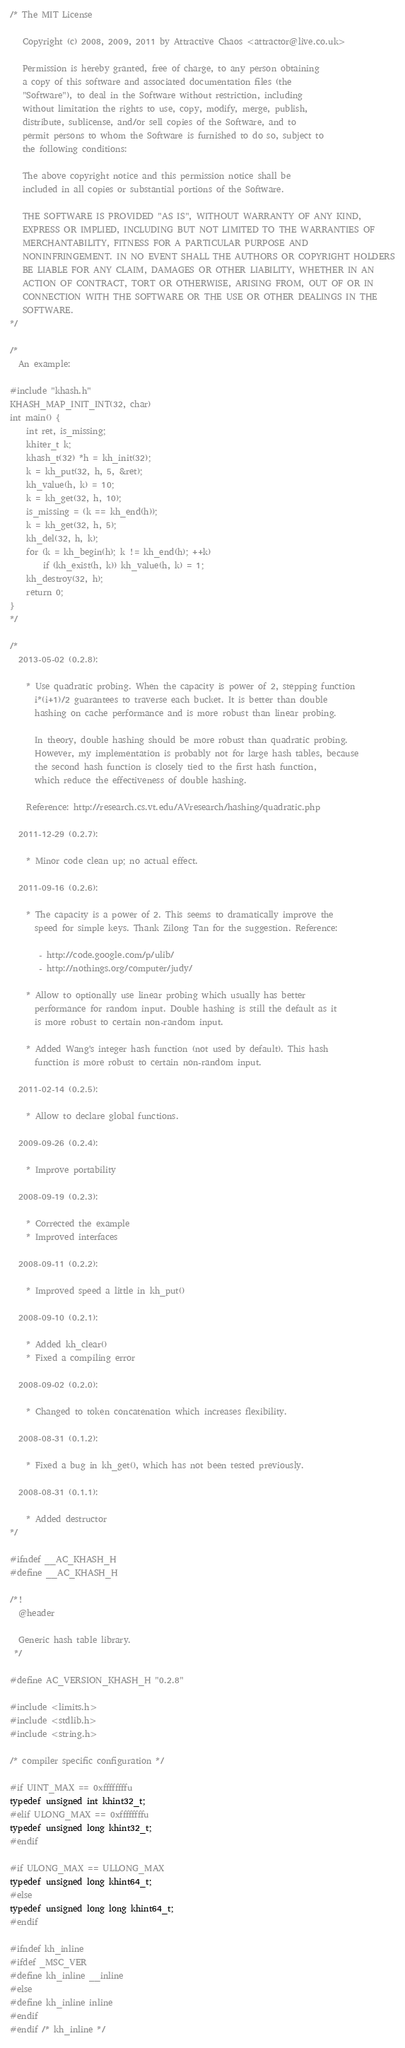Convert code to text. <code><loc_0><loc_0><loc_500><loc_500><_C_>/* The MIT License

   Copyright (c) 2008, 2009, 2011 by Attractive Chaos <attractor@live.co.uk>

   Permission is hereby granted, free of charge, to any person obtaining
   a copy of this software and associated documentation files (the
   "Software"), to deal in the Software without restriction, including
   without limitation the rights to use, copy, modify, merge, publish,
   distribute, sublicense, and/or sell copies of the Software, and to
   permit persons to whom the Software is furnished to do so, subject to
   the following conditions:

   The above copyright notice and this permission notice shall be
   included in all copies or substantial portions of the Software.

   THE SOFTWARE IS PROVIDED "AS IS", WITHOUT WARRANTY OF ANY KIND,
   EXPRESS OR IMPLIED, INCLUDING BUT NOT LIMITED TO THE WARRANTIES OF
   MERCHANTABILITY, FITNESS FOR A PARTICULAR PURPOSE AND
   NONINFRINGEMENT. IN NO EVENT SHALL THE AUTHORS OR COPYRIGHT HOLDERS
   BE LIABLE FOR ANY CLAIM, DAMAGES OR OTHER LIABILITY, WHETHER IN AN
   ACTION OF CONTRACT, TORT OR OTHERWISE, ARISING FROM, OUT OF OR IN
   CONNECTION WITH THE SOFTWARE OR THE USE OR OTHER DEALINGS IN THE
   SOFTWARE.
*/

/*
  An example:

#include "khash.h"
KHASH_MAP_INIT_INT(32, char)
int main() {
    int ret, is_missing;
    khiter_t k;
    khash_t(32) *h = kh_init(32);
    k = kh_put(32, h, 5, &ret);
    kh_value(h, k) = 10;
    k = kh_get(32, h, 10);
    is_missing = (k == kh_end(h));
    k = kh_get(32, h, 5);
    kh_del(32, h, k);
    for (k = kh_begin(h); k != kh_end(h); ++k)
        if (kh_exist(h, k)) kh_value(h, k) = 1;
    kh_destroy(32, h);
    return 0;
}
*/

/*
  2013-05-02 (0.2.8):

    * Use quadratic probing. When the capacity is power of 2, stepping function
      i*(i+1)/2 guarantees to traverse each bucket. It is better than double
      hashing on cache performance and is more robust than linear probing.

      In theory, double hashing should be more robust than quadratic probing.
      However, my implementation is probably not for large hash tables, because
      the second hash function is closely tied to the first hash function,
      which reduce the effectiveness of double hashing.

    Reference: http://research.cs.vt.edu/AVresearch/hashing/quadratic.php

  2011-12-29 (0.2.7):

    * Minor code clean up; no actual effect.

  2011-09-16 (0.2.6):

    * The capacity is a power of 2. This seems to dramatically improve the
      speed for simple keys. Thank Zilong Tan for the suggestion. Reference:

       - http://code.google.com/p/ulib/
       - http://nothings.org/computer/judy/

    * Allow to optionally use linear probing which usually has better
      performance for random input. Double hashing is still the default as it
      is more robust to certain non-random input.

    * Added Wang's integer hash function (not used by default). This hash
      function is more robust to certain non-random input.

  2011-02-14 (0.2.5):

    * Allow to declare global functions.

  2009-09-26 (0.2.4):

    * Improve portability

  2008-09-19 (0.2.3):

    * Corrected the example
    * Improved interfaces

  2008-09-11 (0.2.2):

    * Improved speed a little in kh_put()

  2008-09-10 (0.2.1):

    * Added kh_clear()
    * Fixed a compiling error

  2008-09-02 (0.2.0):

    * Changed to token concatenation which increases flexibility.

  2008-08-31 (0.1.2):

    * Fixed a bug in kh_get(), which has not been tested previously.

  2008-08-31 (0.1.1):

    * Added destructor
*/

#ifndef __AC_KHASH_H
#define __AC_KHASH_H

/*!
  @header

  Generic hash table library.
 */

#define AC_VERSION_KHASH_H "0.2.8"

#include <limits.h>
#include <stdlib.h>
#include <string.h>

/* compiler specific configuration */

#if UINT_MAX == 0xffffffffu
typedef unsigned int khint32_t;
#elif ULONG_MAX == 0xffffffffu
typedef unsigned long khint32_t;
#endif

#if ULONG_MAX == ULLONG_MAX
typedef unsigned long khint64_t;
#else
typedef unsigned long long khint64_t;
#endif

#ifndef kh_inline
#ifdef _MSC_VER
#define kh_inline __inline
#else
#define kh_inline inline
#endif
#endif /* kh_inline */
</code> 